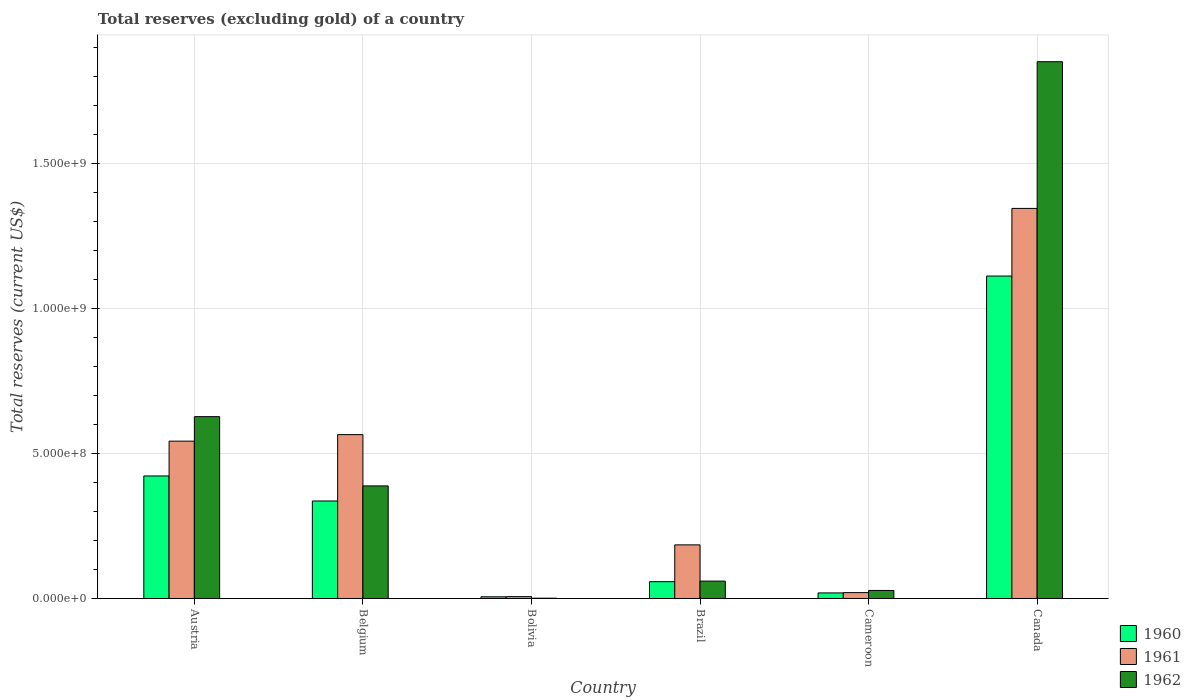How many different coloured bars are there?
Your answer should be compact. 3. Are the number of bars on each tick of the X-axis equal?
Provide a short and direct response. Yes. In how many cases, is the number of bars for a given country not equal to the number of legend labels?
Provide a short and direct response. 0. What is the total reserves (excluding gold) in 1962 in Belgium?
Your answer should be very brief. 3.88e+08. Across all countries, what is the maximum total reserves (excluding gold) in 1962?
Your answer should be compact. 1.85e+09. Across all countries, what is the minimum total reserves (excluding gold) in 1960?
Your answer should be compact. 5.80e+06. In which country was the total reserves (excluding gold) in 1960 maximum?
Provide a short and direct response. Canada. What is the total total reserves (excluding gold) in 1962 in the graph?
Ensure brevity in your answer.  2.96e+09. What is the difference between the total reserves (excluding gold) in 1960 in Belgium and that in Brazil?
Give a very brief answer. 2.78e+08. What is the difference between the total reserves (excluding gold) in 1960 in Bolivia and the total reserves (excluding gold) in 1962 in Cameroon?
Give a very brief answer. -2.19e+07. What is the average total reserves (excluding gold) in 1961 per country?
Ensure brevity in your answer.  4.44e+08. What is the difference between the total reserves (excluding gold) of/in 1960 and total reserves (excluding gold) of/in 1962 in Brazil?
Keep it short and to the point. -2.00e+06. In how many countries, is the total reserves (excluding gold) in 1961 greater than 1700000000 US$?
Offer a very short reply. 0. What is the ratio of the total reserves (excluding gold) in 1961 in Austria to that in Brazil?
Make the answer very short. 2.93. Is the difference between the total reserves (excluding gold) in 1960 in Belgium and Canada greater than the difference between the total reserves (excluding gold) in 1962 in Belgium and Canada?
Offer a very short reply. Yes. What is the difference between the highest and the second highest total reserves (excluding gold) in 1961?
Provide a succinct answer. 2.25e+07. What is the difference between the highest and the lowest total reserves (excluding gold) in 1961?
Provide a succinct answer. 1.34e+09. In how many countries, is the total reserves (excluding gold) in 1962 greater than the average total reserves (excluding gold) in 1962 taken over all countries?
Your answer should be compact. 2. What does the 3rd bar from the left in Canada represents?
Your answer should be very brief. 1962. How many bars are there?
Keep it short and to the point. 18. Where does the legend appear in the graph?
Your answer should be compact. Bottom right. What is the title of the graph?
Offer a very short reply. Total reserves (excluding gold) of a country. Does "1972" appear as one of the legend labels in the graph?
Make the answer very short. No. What is the label or title of the Y-axis?
Provide a short and direct response. Total reserves (current US$). What is the Total reserves (current US$) of 1960 in Austria?
Your answer should be compact. 4.23e+08. What is the Total reserves (current US$) of 1961 in Austria?
Your response must be concise. 5.43e+08. What is the Total reserves (current US$) of 1962 in Austria?
Make the answer very short. 6.27e+08. What is the Total reserves (current US$) in 1960 in Belgium?
Ensure brevity in your answer.  3.36e+08. What is the Total reserves (current US$) of 1961 in Belgium?
Your answer should be very brief. 5.65e+08. What is the Total reserves (current US$) in 1962 in Belgium?
Give a very brief answer. 3.88e+08. What is the Total reserves (current US$) in 1960 in Bolivia?
Your answer should be compact. 5.80e+06. What is the Total reserves (current US$) of 1961 in Bolivia?
Offer a very short reply. 6.40e+06. What is the Total reserves (current US$) of 1960 in Brazil?
Your response must be concise. 5.80e+07. What is the Total reserves (current US$) in 1961 in Brazil?
Provide a short and direct response. 1.85e+08. What is the Total reserves (current US$) of 1962 in Brazil?
Offer a very short reply. 6.00e+07. What is the Total reserves (current US$) of 1960 in Cameroon?
Ensure brevity in your answer.  1.92e+07. What is the Total reserves (current US$) in 1961 in Cameroon?
Offer a very short reply. 2.03e+07. What is the Total reserves (current US$) in 1962 in Cameroon?
Your answer should be very brief. 2.77e+07. What is the Total reserves (current US$) of 1960 in Canada?
Give a very brief answer. 1.11e+09. What is the Total reserves (current US$) in 1961 in Canada?
Ensure brevity in your answer.  1.35e+09. What is the Total reserves (current US$) of 1962 in Canada?
Make the answer very short. 1.85e+09. Across all countries, what is the maximum Total reserves (current US$) in 1960?
Your response must be concise. 1.11e+09. Across all countries, what is the maximum Total reserves (current US$) of 1961?
Ensure brevity in your answer.  1.35e+09. Across all countries, what is the maximum Total reserves (current US$) in 1962?
Keep it short and to the point. 1.85e+09. Across all countries, what is the minimum Total reserves (current US$) in 1960?
Offer a very short reply. 5.80e+06. Across all countries, what is the minimum Total reserves (current US$) in 1961?
Your response must be concise. 6.40e+06. Across all countries, what is the minimum Total reserves (current US$) in 1962?
Give a very brief answer. 1.00e+06. What is the total Total reserves (current US$) of 1960 in the graph?
Offer a terse response. 1.95e+09. What is the total Total reserves (current US$) in 1961 in the graph?
Offer a terse response. 2.67e+09. What is the total Total reserves (current US$) in 1962 in the graph?
Make the answer very short. 2.96e+09. What is the difference between the Total reserves (current US$) in 1960 in Austria and that in Belgium?
Make the answer very short. 8.64e+07. What is the difference between the Total reserves (current US$) in 1961 in Austria and that in Belgium?
Give a very brief answer. -2.25e+07. What is the difference between the Total reserves (current US$) in 1962 in Austria and that in Belgium?
Make the answer very short. 2.39e+08. What is the difference between the Total reserves (current US$) in 1960 in Austria and that in Bolivia?
Your answer should be very brief. 4.17e+08. What is the difference between the Total reserves (current US$) of 1961 in Austria and that in Bolivia?
Ensure brevity in your answer.  5.36e+08. What is the difference between the Total reserves (current US$) of 1962 in Austria and that in Bolivia?
Keep it short and to the point. 6.26e+08. What is the difference between the Total reserves (current US$) in 1960 in Austria and that in Brazil?
Ensure brevity in your answer.  3.65e+08. What is the difference between the Total reserves (current US$) of 1961 in Austria and that in Brazil?
Keep it short and to the point. 3.58e+08. What is the difference between the Total reserves (current US$) in 1962 in Austria and that in Brazil?
Your answer should be very brief. 5.67e+08. What is the difference between the Total reserves (current US$) of 1960 in Austria and that in Cameroon?
Offer a terse response. 4.04e+08. What is the difference between the Total reserves (current US$) in 1961 in Austria and that in Cameroon?
Your answer should be very brief. 5.23e+08. What is the difference between the Total reserves (current US$) in 1962 in Austria and that in Cameroon?
Ensure brevity in your answer.  6.00e+08. What is the difference between the Total reserves (current US$) of 1960 in Austria and that in Canada?
Offer a very short reply. -6.90e+08. What is the difference between the Total reserves (current US$) in 1961 in Austria and that in Canada?
Keep it short and to the point. -8.03e+08. What is the difference between the Total reserves (current US$) in 1962 in Austria and that in Canada?
Give a very brief answer. -1.22e+09. What is the difference between the Total reserves (current US$) of 1960 in Belgium and that in Bolivia?
Give a very brief answer. 3.31e+08. What is the difference between the Total reserves (current US$) in 1961 in Belgium and that in Bolivia?
Your answer should be very brief. 5.59e+08. What is the difference between the Total reserves (current US$) in 1962 in Belgium and that in Bolivia?
Your response must be concise. 3.87e+08. What is the difference between the Total reserves (current US$) of 1960 in Belgium and that in Brazil?
Your answer should be compact. 2.78e+08. What is the difference between the Total reserves (current US$) of 1961 in Belgium and that in Brazil?
Your answer should be compact. 3.80e+08. What is the difference between the Total reserves (current US$) of 1962 in Belgium and that in Brazil?
Provide a short and direct response. 3.28e+08. What is the difference between the Total reserves (current US$) of 1960 in Belgium and that in Cameroon?
Make the answer very short. 3.17e+08. What is the difference between the Total reserves (current US$) in 1961 in Belgium and that in Cameroon?
Your response must be concise. 5.45e+08. What is the difference between the Total reserves (current US$) in 1962 in Belgium and that in Cameroon?
Provide a succinct answer. 3.61e+08. What is the difference between the Total reserves (current US$) of 1960 in Belgium and that in Canada?
Give a very brief answer. -7.76e+08. What is the difference between the Total reserves (current US$) of 1961 in Belgium and that in Canada?
Give a very brief answer. -7.80e+08. What is the difference between the Total reserves (current US$) in 1962 in Belgium and that in Canada?
Give a very brief answer. -1.46e+09. What is the difference between the Total reserves (current US$) in 1960 in Bolivia and that in Brazil?
Give a very brief answer. -5.22e+07. What is the difference between the Total reserves (current US$) in 1961 in Bolivia and that in Brazil?
Offer a terse response. -1.79e+08. What is the difference between the Total reserves (current US$) in 1962 in Bolivia and that in Brazil?
Your response must be concise. -5.90e+07. What is the difference between the Total reserves (current US$) in 1960 in Bolivia and that in Cameroon?
Offer a terse response. -1.34e+07. What is the difference between the Total reserves (current US$) of 1961 in Bolivia and that in Cameroon?
Offer a very short reply. -1.39e+07. What is the difference between the Total reserves (current US$) in 1962 in Bolivia and that in Cameroon?
Give a very brief answer. -2.67e+07. What is the difference between the Total reserves (current US$) in 1960 in Bolivia and that in Canada?
Provide a succinct answer. -1.11e+09. What is the difference between the Total reserves (current US$) of 1961 in Bolivia and that in Canada?
Provide a short and direct response. -1.34e+09. What is the difference between the Total reserves (current US$) of 1962 in Bolivia and that in Canada?
Ensure brevity in your answer.  -1.85e+09. What is the difference between the Total reserves (current US$) of 1960 in Brazil and that in Cameroon?
Provide a short and direct response. 3.88e+07. What is the difference between the Total reserves (current US$) of 1961 in Brazil and that in Cameroon?
Make the answer very short. 1.65e+08. What is the difference between the Total reserves (current US$) in 1962 in Brazil and that in Cameroon?
Provide a succinct answer. 3.23e+07. What is the difference between the Total reserves (current US$) in 1960 in Brazil and that in Canada?
Give a very brief answer. -1.05e+09. What is the difference between the Total reserves (current US$) in 1961 in Brazil and that in Canada?
Make the answer very short. -1.16e+09. What is the difference between the Total reserves (current US$) in 1962 in Brazil and that in Canada?
Offer a very short reply. -1.79e+09. What is the difference between the Total reserves (current US$) of 1960 in Cameroon and that in Canada?
Offer a terse response. -1.09e+09. What is the difference between the Total reserves (current US$) of 1961 in Cameroon and that in Canada?
Provide a succinct answer. -1.33e+09. What is the difference between the Total reserves (current US$) of 1962 in Cameroon and that in Canada?
Your answer should be very brief. -1.82e+09. What is the difference between the Total reserves (current US$) of 1960 in Austria and the Total reserves (current US$) of 1961 in Belgium?
Provide a succinct answer. -1.43e+08. What is the difference between the Total reserves (current US$) of 1960 in Austria and the Total reserves (current US$) of 1962 in Belgium?
Offer a terse response. 3.44e+07. What is the difference between the Total reserves (current US$) of 1961 in Austria and the Total reserves (current US$) of 1962 in Belgium?
Ensure brevity in your answer.  1.54e+08. What is the difference between the Total reserves (current US$) in 1960 in Austria and the Total reserves (current US$) in 1961 in Bolivia?
Your answer should be very brief. 4.16e+08. What is the difference between the Total reserves (current US$) of 1960 in Austria and the Total reserves (current US$) of 1962 in Bolivia?
Ensure brevity in your answer.  4.22e+08. What is the difference between the Total reserves (current US$) in 1961 in Austria and the Total reserves (current US$) in 1962 in Bolivia?
Offer a very short reply. 5.42e+08. What is the difference between the Total reserves (current US$) of 1960 in Austria and the Total reserves (current US$) of 1961 in Brazil?
Give a very brief answer. 2.38e+08. What is the difference between the Total reserves (current US$) in 1960 in Austria and the Total reserves (current US$) in 1962 in Brazil?
Give a very brief answer. 3.63e+08. What is the difference between the Total reserves (current US$) of 1961 in Austria and the Total reserves (current US$) of 1962 in Brazil?
Offer a very short reply. 4.83e+08. What is the difference between the Total reserves (current US$) in 1960 in Austria and the Total reserves (current US$) in 1961 in Cameroon?
Make the answer very short. 4.02e+08. What is the difference between the Total reserves (current US$) of 1960 in Austria and the Total reserves (current US$) of 1962 in Cameroon?
Give a very brief answer. 3.95e+08. What is the difference between the Total reserves (current US$) in 1961 in Austria and the Total reserves (current US$) in 1962 in Cameroon?
Provide a short and direct response. 5.15e+08. What is the difference between the Total reserves (current US$) of 1960 in Austria and the Total reserves (current US$) of 1961 in Canada?
Your answer should be compact. -9.23e+08. What is the difference between the Total reserves (current US$) of 1960 in Austria and the Total reserves (current US$) of 1962 in Canada?
Make the answer very short. -1.43e+09. What is the difference between the Total reserves (current US$) of 1961 in Austria and the Total reserves (current US$) of 1962 in Canada?
Give a very brief answer. -1.31e+09. What is the difference between the Total reserves (current US$) in 1960 in Belgium and the Total reserves (current US$) in 1961 in Bolivia?
Provide a succinct answer. 3.30e+08. What is the difference between the Total reserves (current US$) in 1960 in Belgium and the Total reserves (current US$) in 1962 in Bolivia?
Your response must be concise. 3.35e+08. What is the difference between the Total reserves (current US$) in 1961 in Belgium and the Total reserves (current US$) in 1962 in Bolivia?
Provide a short and direct response. 5.64e+08. What is the difference between the Total reserves (current US$) in 1960 in Belgium and the Total reserves (current US$) in 1961 in Brazil?
Offer a terse response. 1.51e+08. What is the difference between the Total reserves (current US$) of 1960 in Belgium and the Total reserves (current US$) of 1962 in Brazil?
Provide a succinct answer. 2.76e+08. What is the difference between the Total reserves (current US$) of 1961 in Belgium and the Total reserves (current US$) of 1962 in Brazil?
Offer a very short reply. 5.05e+08. What is the difference between the Total reserves (current US$) in 1960 in Belgium and the Total reserves (current US$) in 1961 in Cameroon?
Provide a short and direct response. 3.16e+08. What is the difference between the Total reserves (current US$) in 1960 in Belgium and the Total reserves (current US$) in 1962 in Cameroon?
Provide a succinct answer. 3.09e+08. What is the difference between the Total reserves (current US$) in 1961 in Belgium and the Total reserves (current US$) in 1962 in Cameroon?
Offer a terse response. 5.38e+08. What is the difference between the Total reserves (current US$) in 1960 in Belgium and the Total reserves (current US$) in 1961 in Canada?
Offer a very short reply. -1.01e+09. What is the difference between the Total reserves (current US$) in 1960 in Belgium and the Total reserves (current US$) in 1962 in Canada?
Your answer should be compact. -1.52e+09. What is the difference between the Total reserves (current US$) in 1961 in Belgium and the Total reserves (current US$) in 1962 in Canada?
Keep it short and to the point. -1.29e+09. What is the difference between the Total reserves (current US$) in 1960 in Bolivia and the Total reserves (current US$) in 1961 in Brazil?
Provide a short and direct response. -1.79e+08. What is the difference between the Total reserves (current US$) in 1960 in Bolivia and the Total reserves (current US$) in 1962 in Brazil?
Keep it short and to the point. -5.42e+07. What is the difference between the Total reserves (current US$) of 1961 in Bolivia and the Total reserves (current US$) of 1962 in Brazil?
Ensure brevity in your answer.  -5.36e+07. What is the difference between the Total reserves (current US$) of 1960 in Bolivia and the Total reserves (current US$) of 1961 in Cameroon?
Your response must be concise. -1.45e+07. What is the difference between the Total reserves (current US$) of 1960 in Bolivia and the Total reserves (current US$) of 1962 in Cameroon?
Offer a very short reply. -2.19e+07. What is the difference between the Total reserves (current US$) in 1961 in Bolivia and the Total reserves (current US$) in 1962 in Cameroon?
Make the answer very short. -2.13e+07. What is the difference between the Total reserves (current US$) in 1960 in Bolivia and the Total reserves (current US$) in 1961 in Canada?
Ensure brevity in your answer.  -1.34e+09. What is the difference between the Total reserves (current US$) in 1960 in Bolivia and the Total reserves (current US$) in 1962 in Canada?
Ensure brevity in your answer.  -1.85e+09. What is the difference between the Total reserves (current US$) in 1961 in Bolivia and the Total reserves (current US$) in 1962 in Canada?
Give a very brief answer. -1.85e+09. What is the difference between the Total reserves (current US$) of 1960 in Brazil and the Total reserves (current US$) of 1961 in Cameroon?
Offer a terse response. 3.77e+07. What is the difference between the Total reserves (current US$) in 1960 in Brazil and the Total reserves (current US$) in 1962 in Cameroon?
Your answer should be compact. 3.03e+07. What is the difference between the Total reserves (current US$) in 1961 in Brazil and the Total reserves (current US$) in 1962 in Cameroon?
Offer a very short reply. 1.57e+08. What is the difference between the Total reserves (current US$) in 1960 in Brazil and the Total reserves (current US$) in 1961 in Canada?
Provide a succinct answer. -1.29e+09. What is the difference between the Total reserves (current US$) in 1960 in Brazil and the Total reserves (current US$) in 1962 in Canada?
Provide a short and direct response. -1.79e+09. What is the difference between the Total reserves (current US$) in 1961 in Brazil and the Total reserves (current US$) in 1962 in Canada?
Offer a terse response. -1.67e+09. What is the difference between the Total reserves (current US$) of 1960 in Cameroon and the Total reserves (current US$) of 1961 in Canada?
Give a very brief answer. -1.33e+09. What is the difference between the Total reserves (current US$) of 1960 in Cameroon and the Total reserves (current US$) of 1962 in Canada?
Your answer should be compact. -1.83e+09. What is the difference between the Total reserves (current US$) in 1961 in Cameroon and the Total reserves (current US$) in 1962 in Canada?
Give a very brief answer. -1.83e+09. What is the average Total reserves (current US$) in 1960 per country?
Offer a terse response. 3.26e+08. What is the average Total reserves (current US$) in 1961 per country?
Provide a short and direct response. 4.44e+08. What is the average Total reserves (current US$) in 1962 per country?
Make the answer very short. 4.93e+08. What is the difference between the Total reserves (current US$) of 1960 and Total reserves (current US$) of 1961 in Austria?
Your answer should be very brief. -1.20e+08. What is the difference between the Total reserves (current US$) in 1960 and Total reserves (current US$) in 1962 in Austria?
Offer a very short reply. -2.05e+08. What is the difference between the Total reserves (current US$) in 1961 and Total reserves (current US$) in 1962 in Austria?
Keep it short and to the point. -8.45e+07. What is the difference between the Total reserves (current US$) of 1960 and Total reserves (current US$) of 1961 in Belgium?
Provide a succinct answer. -2.29e+08. What is the difference between the Total reserves (current US$) in 1960 and Total reserves (current US$) in 1962 in Belgium?
Your answer should be very brief. -5.20e+07. What is the difference between the Total reserves (current US$) of 1961 and Total reserves (current US$) of 1962 in Belgium?
Your answer should be very brief. 1.77e+08. What is the difference between the Total reserves (current US$) in 1960 and Total reserves (current US$) in 1961 in Bolivia?
Offer a very short reply. -6.00e+05. What is the difference between the Total reserves (current US$) of 1960 and Total reserves (current US$) of 1962 in Bolivia?
Your answer should be very brief. 4.80e+06. What is the difference between the Total reserves (current US$) of 1961 and Total reserves (current US$) of 1962 in Bolivia?
Provide a short and direct response. 5.40e+06. What is the difference between the Total reserves (current US$) of 1960 and Total reserves (current US$) of 1961 in Brazil?
Your response must be concise. -1.27e+08. What is the difference between the Total reserves (current US$) of 1960 and Total reserves (current US$) of 1962 in Brazil?
Offer a very short reply. -2.00e+06. What is the difference between the Total reserves (current US$) in 1961 and Total reserves (current US$) in 1962 in Brazil?
Offer a very short reply. 1.25e+08. What is the difference between the Total reserves (current US$) in 1960 and Total reserves (current US$) in 1961 in Cameroon?
Provide a short and direct response. -1.06e+06. What is the difference between the Total reserves (current US$) in 1960 and Total reserves (current US$) in 1962 in Cameroon?
Keep it short and to the point. -8.47e+06. What is the difference between the Total reserves (current US$) of 1961 and Total reserves (current US$) of 1962 in Cameroon?
Give a very brief answer. -7.41e+06. What is the difference between the Total reserves (current US$) in 1960 and Total reserves (current US$) in 1961 in Canada?
Give a very brief answer. -2.33e+08. What is the difference between the Total reserves (current US$) of 1960 and Total reserves (current US$) of 1962 in Canada?
Your response must be concise. -7.39e+08. What is the difference between the Total reserves (current US$) of 1961 and Total reserves (current US$) of 1962 in Canada?
Ensure brevity in your answer.  -5.06e+08. What is the ratio of the Total reserves (current US$) in 1960 in Austria to that in Belgium?
Make the answer very short. 1.26. What is the ratio of the Total reserves (current US$) of 1961 in Austria to that in Belgium?
Offer a very short reply. 0.96. What is the ratio of the Total reserves (current US$) of 1962 in Austria to that in Belgium?
Provide a succinct answer. 1.62. What is the ratio of the Total reserves (current US$) in 1960 in Austria to that in Bolivia?
Offer a terse response. 72.89. What is the ratio of the Total reserves (current US$) of 1961 in Austria to that in Bolivia?
Offer a terse response. 84.82. What is the ratio of the Total reserves (current US$) of 1962 in Austria to that in Bolivia?
Provide a short and direct response. 627.38. What is the ratio of the Total reserves (current US$) of 1960 in Austria to that in Brazil?
Your answer should be very brief. 7.29. What is the ratio of the Total reserves (current US$) of 1961 in Austria to that in Brazil?
Your answer should be very brief. 2.93. What is the ratio of the Total reserves (current US$) of 1962 in Austria to that in Brazil?
Give a very brief answer. 10.46. What is the ratio of the Total reserves (current US$) in 1960 in Austria to that in Cameroon?
Make the answer very short. 21.97. What is the ratio of the Total reserves (current US$) in 1961 in Austria to that in Cameroon?
Ensure brevity in your answer.  26.74. What is the ratio of the Total reserves (current US$) in 1962 in Austria to that in Cameroon?
Offer a terse response. 22.64. What is the ratio of the Total reserves (current US$) in 1960 in Austria to that in Canada?
Ensure brevity in your answer.  0.38. What is the ratio of the Total reserves (current US$) of 1961 in Austria to that in Canada?
Your answer should be compact. 0.4. What is the ratio of the Total reserves (current US$) of 1962 in Austria to that in Canada?
Ensure brevity in your answer.  0.34. What is the ratio of the Total reserves (current US$) of 1960 in Belgium to that in Bolivia?
Offer a very short reply. 58. What is the ratio of the Total reserves (current US$) in 1961 in Belgium to that in Bolivia?
Your answer should be compact. 88.34. What is the ratio of the Total reserves (current US$) of 1962 in Belgium to that in Bolivia?
Offer a terse response. 388.39. What is the ratio of the Total reserves (current US$) of 1960 in Belgium to that in Brazil?
Make the answer very short. 5.8. What is the ratio of the Total reserves (current US$) in 1961 in Belgium to that in Brazil?
Your answer should be very brief. 3.06. What is the ratio of the Total reserves (current US$) of 1962 in Belgium to that in Brazil?
Keep it short and to the point. 6.47. What is the ratio of the Total reserves (current US$) in 1960 in Belgium to that in Cameroon?
Offer a terse response. 17.48. What is the ratio of the Total reserves (current US$) in 1961 in Belgium to that in Cameroon?
Offer a very short reply. 27.85. What is the ratio of the Total reserves (current US$) of 1962 in Belgium to that in Cameroon?
Give a very brief answer. 14.02. What is the ratio of the Total reserves (current US$) in 1960 in Belgium to that in Canada?
Ensure brevity in your answer.  0.3. What is the ratio of the Total reserves (current US$) of 1961 in Belgium to that in Canada?
Your answer should be compact. 0.42. What is the ratio of the Total reserves (current US$) in 1962 in Belgium to that in Canada?
Your response must be concise. 0.21. What is the ratio of the Total reserves (current US$) in 1961 in Bolivia to that in Brazil?
Make the answer very short. 0.03. What is the ratio of the Total reserves (current US$) of 1962 in Bolivia to that in Brazil?
Ensure brevity in your answer.  0.02. What is the ratio of the Total reserves (current US$) in 1960 in Bolivia to that in Cameroon?
Provide a short and direct response. 0.3. What is the ratio of the Total reserves (current US$) in 1961 in Bolivia to that in Cameroon?
Offer a terse response. 0.32. What is the ratio of the Total reserves (current US$) of 1962 in Bolivia to that in Cameroon?
Your response must be concise. 0.04. What is the ratio of the Total reserves (current US$) of 1960 in Bolivia to that in Canada?
Your answer should be very brief. 0.01. What is the ratio of the Total reserves (current US$) of 1961 in Bolivia to that in Canada?
Offer a very short reply. 0. What is the ratio of the Total reserves (current US$) of 1960 in Brazil to that in Cameroon?
Your answer should be very brief. 3.01. What is the ratio of the Total reserves (current US$) in 1961 in Brazil to that in Cameroon?
Make the answer very short. 9.11. What is the ratio of the Total reserves (current US$) of 1962 in Brazil to that in Cameroon?
Provide a short and direct response. 2.17. What is the ratio of the Total reserves (current US$) in 1960 in Brazil to that in Canada?
Your answer should be very brief. 0.05. What is the ratio of the Total reserves (current US$) in 1961 in Brazil to that in Canada?
Give a very brief answer. 0.14. What is the ratio of the Total reserves (current US$) of 1962 in Brazil to that in Canada?
Offer a very short reply. 0.03. What is the ratio of the Total reserves (current US$) in 1960 in Cameroon to that in Canada?
Provide a short and direct response. 0.02. What is the ratio of the Total reserves (current US$) of 1961 in Cameroon to that in Canada?
Offer a terse response. 0.02. What is the ratio of the Total reserves (current US$) in 1962 in Cameroon to that in Canada?
Your response must be concise. 0.01. What is the difference between the highest and the second highest Total reserves (current US$) in 1960?
Offer a very short reply. 6.90e+08. What is the difference between the highest and the second highest Total reserves (current US$) in 1961?
Your answer should be very brief. 7.80e+08. What is the difference between the highest and the second highest Total reserves (current US$) in 1962?
Your response must be concise. 1.22e+09. What is the difference between the highest and the lowest Total reserves (current US$) in 1960?
Offer a very short reply. 1.11e+09. What is the difference between the highest and the lowest Total reserves (current US$) in 1961?
Keep it short and to the point. 1.34e+09. What is the difference between the highest and the lowest Total reserves (current US$) in 1962?
Provide a succinct answer. 1.85e+09. 